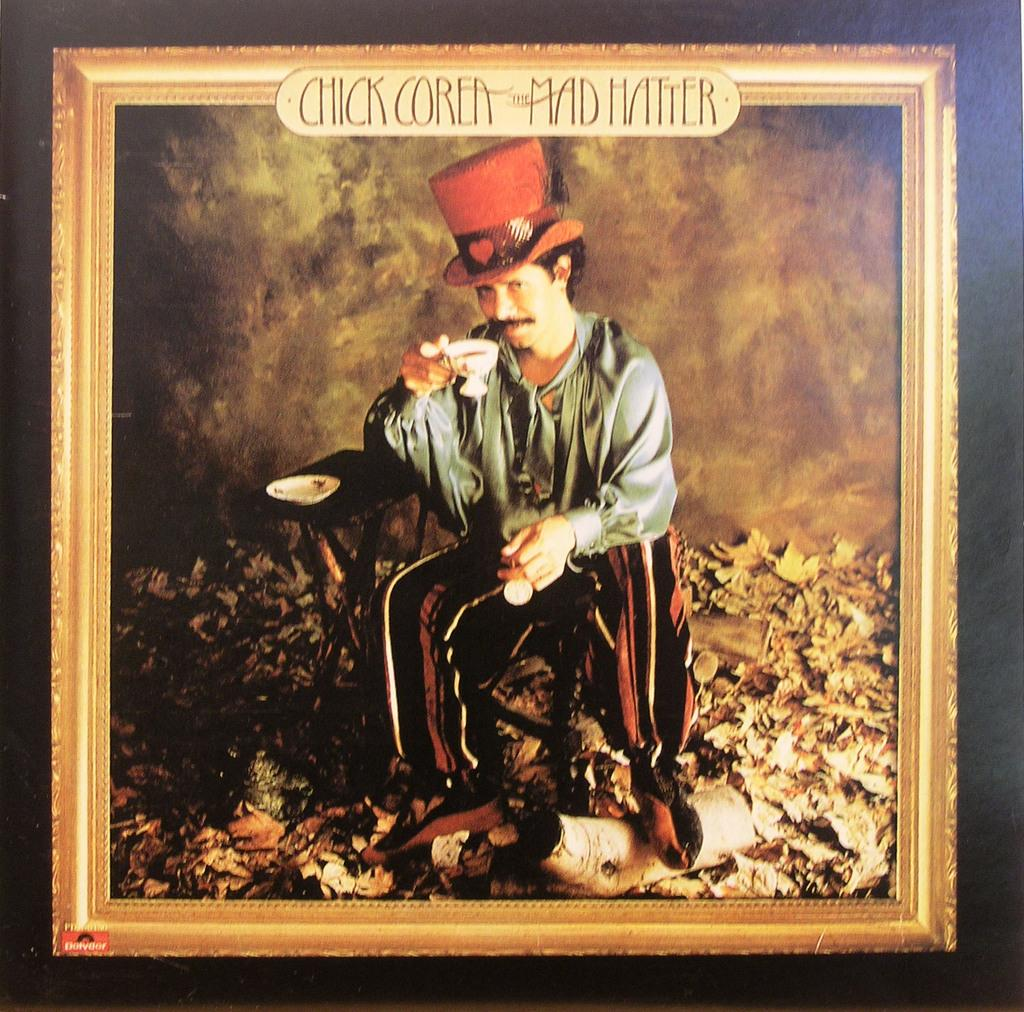<image>
Present a compact description of the photo's key features. Picture framed of a man wearing a red hat and says Mad Hatter on top. 